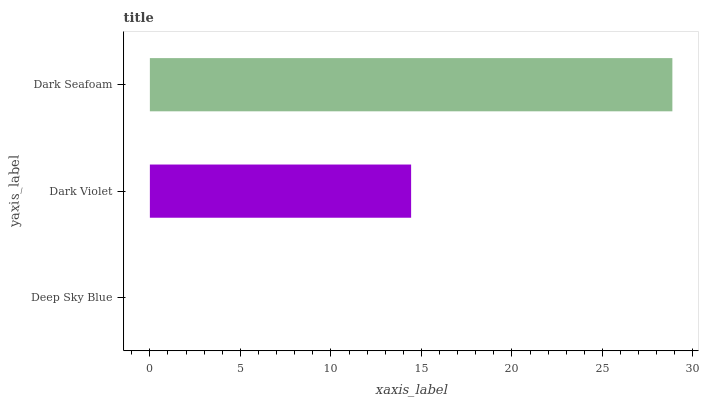Is Deep Sky Blue the minimum?
Answer yes or no. Yes. Is Dark Seafoam the maximum?
Answer yes or no. Yes. Is Dark Violet the minimum?
Answer yes or no. No. Is Dark Violet the maximum?
Answer yes or no. No. Is Dark Violet greater than Deep Sky Blue?
Answer yes or no. Yes. Is Deep Sky Blue less than Dark Violet?
Answer yes or no. Yes. Is Deep Sky Blue greater than Dark Violet?
Answer yes or no. No. Is Dark Violet less than Deep Sky Blue?
Answer yes or no. No. Is Dark Violet the high median?
Answer yes or no. Yes. Is Dark Violet the low median?
Answer yes or no. Yes. Is Deep Sky Blue the high median?
Answer yes or no. No. Is Dark Seafoam the low median?
Answer yes or no. No. 